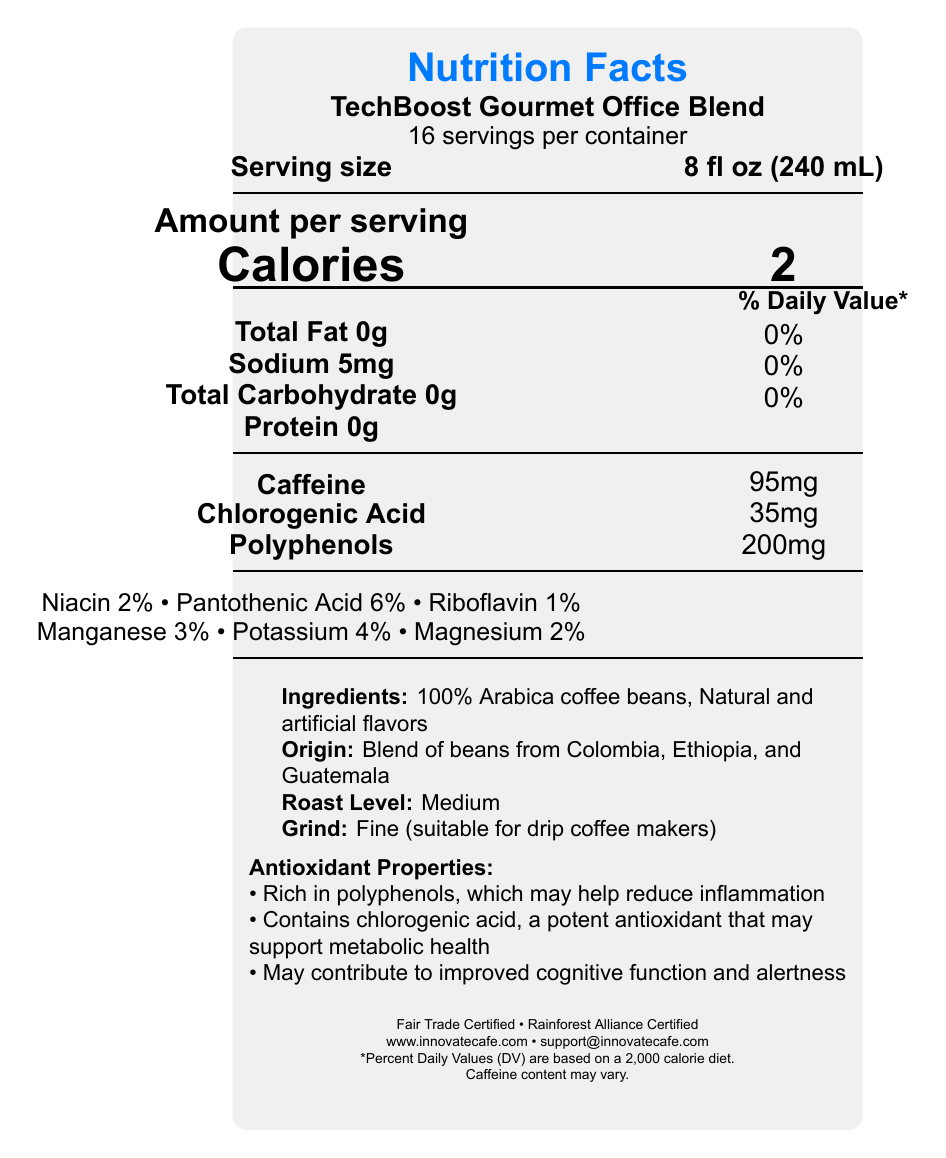what is the serving size for TechBoost Gourmet Office Blend? The serving size for the coffee blend, as mentioned under the "Serving size" section, is 8 fl oz (240 mL).
Answer: 8 fl oz (240 mL) how much caffeine does one serving contain? The amount of caffeine per serving is listed as 95mg under the "Amount per serving" section.
Answer: 95mg which antioxidant compounds are present in the coffee blend? The label includes the amounts of chlorogenic acid (35mg) and polyphenols (200mg) as antioxidant compounds in the coffee blend.
Answer: Chlorogenic acid and polyphenols where does TechBoost source its coffee beans from? The coffee blend origin is indicated as a blend of beans from Colombia, Ethiopia, and Guatemala under the "Origin" section.
Answer: Colombia, Ethiopia, and Guatemala what is the recommended storage condition for this coffee? The storage instructions state that the coffee should be stored in an airtight container in a cool, dry place away from direct sunlight.
Answer: Store in an airtight container in a cool, dry place away from direct sunlight describe the roasting and grind level of this coffee blend The document indicates that the coffee has a medium roast level and a fine grind, suitable for drip coffee makers.
Answer: Medium roast, Fine grind how many calories are in one serving? A. 0 B. 2 C. 5 D. 10 The label specifies that each serving contains 2 calories.
Answer: B which vitamins and minerals are present in this coffee blend, and what are their % Daily Values? The document lists various vitamins and minerals along with their corresponding % Daily Values under the "Vitamins and Minerals" section.
Answer: Niacin 2%, Pantothenic Acid 6%, Riboflavin 1%, Manganese 3%, Potassium 4%, Magnesium 2% the coffee blend supports metabolic health due to which compound? A. Polyphenols B. Chlorogenic acid C. Magnesium D. Niacin The antioxidant properties section states that chlorogenic acid may support metabolic health.
Answer: B are there any artificial flavors in this coffee blend? The ingredients list mentions "Natural and artificial flavors," indicating the presence of artificial flavors.
Answer: Yes does the coffee blend have any certifications? The document states that the coffee blend is Fair Trade Certified and Rainforest Alliance Certified.
Answer: Yes summarize the main benefits of TechBoost Gourmet Office Blend's antioxidant properties. The antioxidant properties section outlines that the blend is rich in polyphenols, contains chlorogenic acid which may support metabolic health, and may contribute to improved cognitive function and alertness.
Answer: The coffee blend is rich in polyphenols which may help reduce inflammation, contains chlorogenic acid that supports metabolic health, and may improve cognitive function and alertness. how much protein does one serving of this coffee blend contain? The label shows that each serving contains 0g of protein under the "Amount per serving" section.
Answer: 0g how many servings are there in one container? The document indicates that there are 16 servings per container.
Answer: 16 how many polyphenols are present in one serving of this coffee blend? The "Amount per serving" section lists the polyphenol content as 200mg per serving.
Answer: 200mg what is the website for InnovateCafe Roasters? The contact information at the bottom of the document provides the website as www.innovatecafe.com.
Answer: www.innovatecafe.com what are the detailed brewing instructions for this coffee blend? The brewing instructions detail using 2 tablespoons (10g) of ground coffee per 6 fl oz (180 mL) of cold, filtered water and suggest brewing using your preferred method.
Answer: Use 2 tablespoons (10g) of ground coffee per 6 fl oz (180 mL) of cold, filtered water. Brew using your preferred method. what is the origin of the natural flavors used in this coffee blend? The document only states "Natural and artificial flavors" but does not specify the origin of the natural flavors.
Answer: Not enough information 